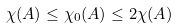Convert formula to latex. <formula><loc_0><loc_0><loc_500><loc_500>\chi ( A ) \leq \chi _ { 0 } ( A ) \leq 2 \chi ( A )</formula> 